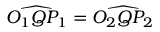Convert formula to latex. <formula><loc_0><loc_0><loc_500><loc_500>{ \widehat { O _ { 1 } Q P _ { 1 } } } = { \widehat { O _ { 2 } Q P _ { 2 } } }</formula> 